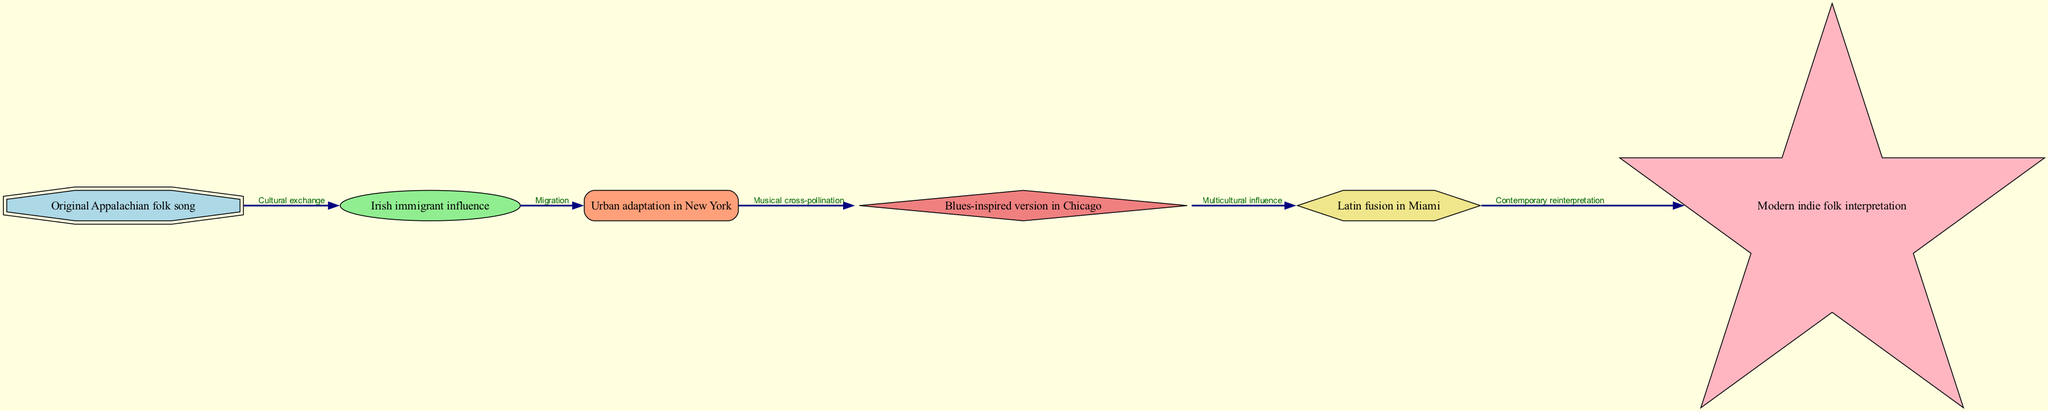What is the first node in the flow chart? The first node in the flow chart is labeled "Original Appalachian folk song". Since the flow chart begins with this node, it represents the starting point of the evolution of the folk song.
Answer: Original Appalachian folk song How many nodes are present in the diagram? By counting the distinct nodes in the diagram, we find there are six unique nodes that represent various stages of the folk song's evolution.
Answer: 6 What connection leads from Irish immigrant influence to Urban adaptation in New York? The connection between these two nodes is labeled "Migration". This indicates that the movement of Irish immigrants significantly influenced the adaptation of the folk song in urban settings.
Answer: Migration Which node follows Blues-inspired version in Chicago? The node that follows is labeled "Latin fusion in Miami", indicating that the Blues-inspired version in Chicago led to the incorporation of Latin musical elements in Miami.
Answer: Latin fusion in Miami What is the relationship between Urban adaptation in New York and Blues-inspired version in Chicago? The relationship is labeled "Musical cross-pollination". This suggests that the musical styles from New York influenced the development of the Blues-inspired version in Chicago, highlighting the blending of cultural elements.
Answer: Musical cross-pollination Which node ends the flow chart? The last node in the flow chart is "Modern indie folk interpretation", indicating that the evolution of the folk song culminates in this contemporary reinterpretation.
Answer: Modern indie folk interpretation What type of node is the Original Appalachian folk song? The node type for "Original Appalachian folk song" is a double octagon. This specific shape is used to denote the starting point or foundational aspect of the diagram.
Answer: double octagon What type of influence is indicated between Blues-inspired version in Chicago and Latin fusion in Miami? The influence indicated is "Multicultural influence", which highlights the diverse musical styles converging in Miami as a result of the Chicago interpretation.
Answer: Multicultural influence 